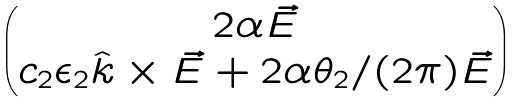<formula> <loc_0><loc_0><loc_500><loc_500>\begin{pmatrix} 2 \alpha \vec { E } \\ c _ { 2 } \epsilon _ { 2 } \hat { k } \times \vec { E } + 2 \alpha \theta _ { 2 } / ( 2 \pi ) \vec { E } \end{pmatrix}</formula> 